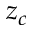Convert formula to latex. <formula><loc_0><loc_0><loc_500><loc_500>z _ { c }</formula> 